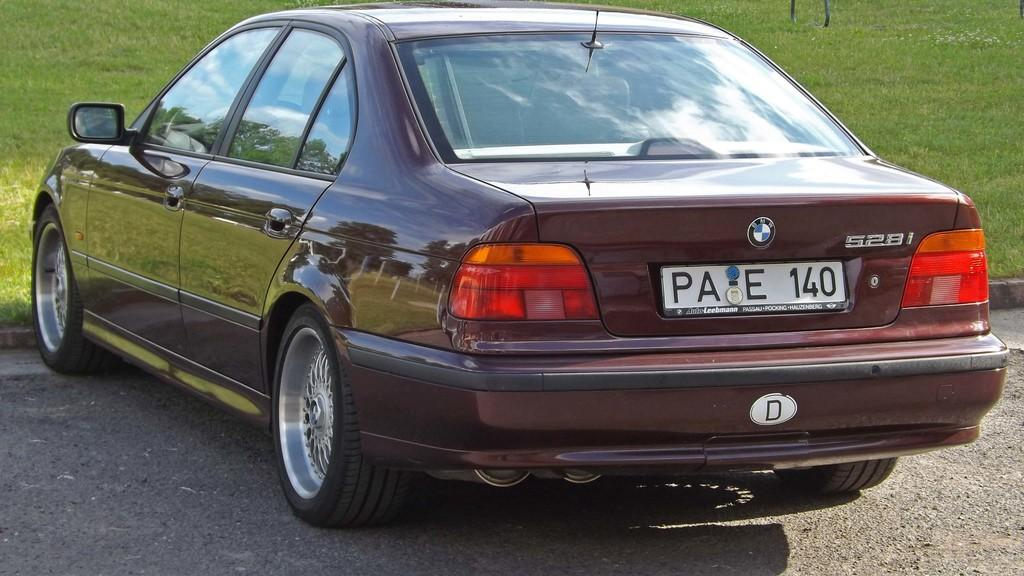What is the main subject of the image? The main subject of the image is a car. What type of natural environment can be seen in the background of the image? There is grass visible in the background of the image. What type of sign can be seen on the car in the image? There is no sign visible on the car in the image. What is the limit of the car's speed in the image? There is no information about the car's speed or any speed limit in the image. 